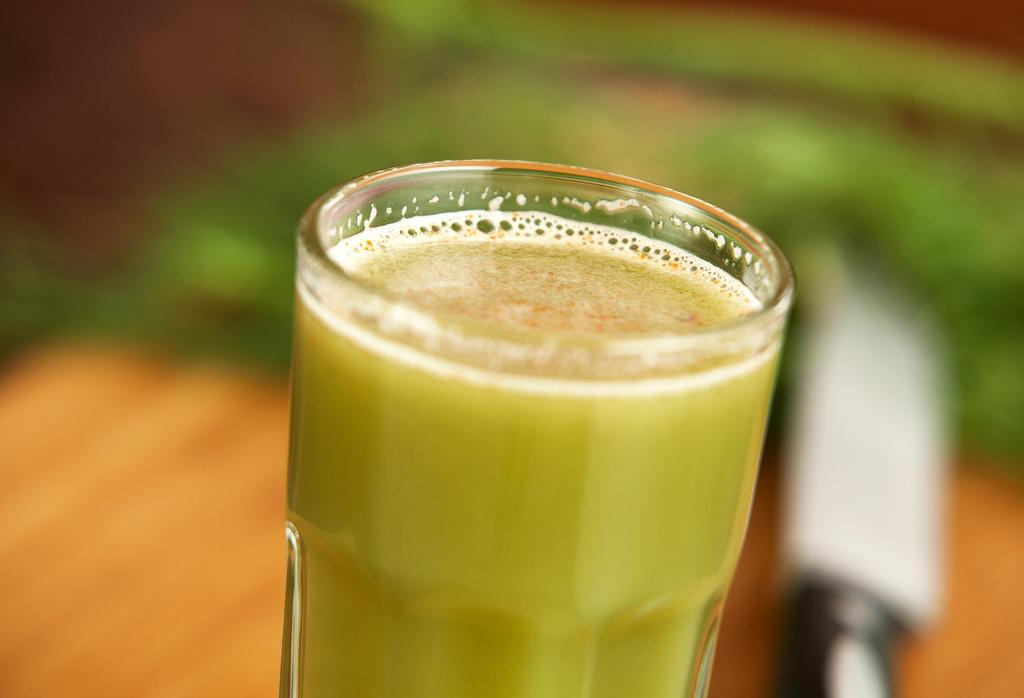What is contained in the glass that is visible in the image? There is a beverage in a glass in the image. Where is the glass located in the image? The glass is placed on a table in the image. What degree does the window have in the image? There is no window present in the image, so it is not possible to determine the degree of any window. 